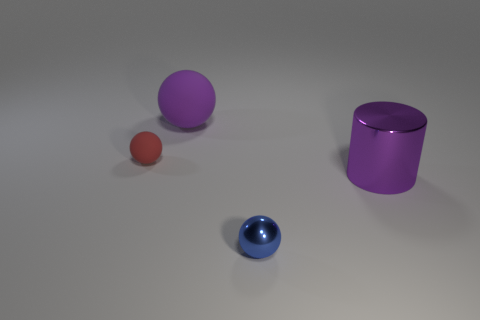Add 4 blue balls. How many objects exist? 8 Subtract all spheres. How many objects are left? 1 Add 3 yellow matte cylinders. How many yellow matte cylinders exist? 3 Subtract 1 purple cylinders. How many objects are left? 3 Subtract all blue objects. Subtract all blue shiny spheres. How many objects are left? 2 Add 2 shiny spheres. How many shiny spheres are left? 3 